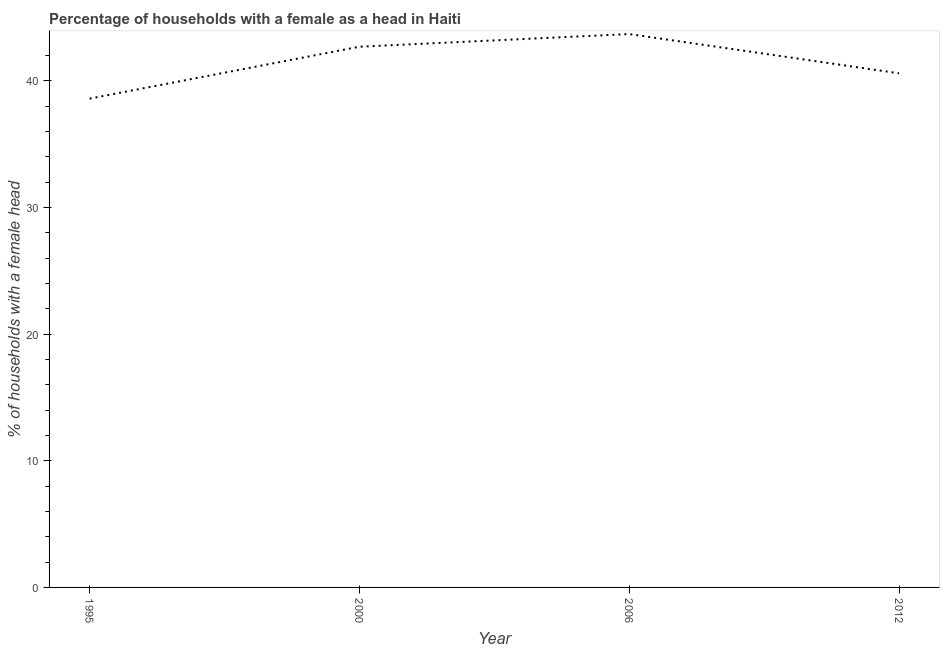What is the number of female supervised households in 2012?
Provide a succinct answer. 40.6. Across all years, what is the maximum number of female supervised households?
Provide a succinct answer. 43.7. Across all years, what is the minimum number of female supervised households?
Provide a succinct answer. 38.6. In which year was the number of female supervised households maximum?
Make the answer very short. 2006. What is the sum of the number of female supervised households?
Your response must be concise. 165.6. What is the difference between the number of female supervised households in 1995 and 2000?
Keep it short and to the point. -4.1. What is the average number of female supervised households per year?
Provide a short and direct response. 41.4. What is the median number of female supervised households?
Your response must be concise. 41.65. What is the ratio of the number of female supervised households in 2006 to that in 2012?
Offer a terse response. 1.08. Is the sum of the number of female supervised households in 1995 and 2006 greater than the maximum number of female supervised households across all years?
Give a very brief answer. Yes. What is the difference between the highest and the lowest number of female supervised households?
Make the answer very short. 5.1. Are the values on the major ticks of Y-axis written in scientific E-notation?
Your response must be concise. No. Does the graph contain any zero values?
Make the answer very short. No. Does the graph contain grids?
Provide a short and direct response. No. What is the title of the graph?
Offer a terse response. Percentage of households with a female as a head in Haiti. What is the label or title of the Y-axis?
Provide a short and direct response. % of households with a female head. What is the % of households with a female head in 1995?
Offer a terse response. 38.6. What is the % of households with a female head in 2000?
Give a very brief answer. 42.7. What is the % of households with a female head of 2006?
Provide a succinct answer. 43.7. What is the % of households with a female head of 2012?
Ensure brevity in your answer.  40.6. What is the difference between the % of households with a female head in 1995 and 2006?
Ensure brevity in your answer.  -5.1. What is the difference between the % of households with a female head in 1995 and 2012?
Ensure brevity in your answer.  -2. What is the difference between the % of households with a female head in 2006 and 2012?
Offer a terse response. 3.1. What is the ratio of the % of households with a female head in 1995 to that in 2000?
Your answer should be compact. 0.9. What is the ratio of the % of households with a female head in 1995 to that in 2006?
Your response must be concise. 0.88. What is the ratio of the % of households with a female head in 1995 to that in 2012?
Provide a succinct answer. 0.95. What is the ratio of the % of households with a female head in 2000 to that in 2006?
Provide a short and direct response. 0.98. What is the ratio of the % of households with a female head in 2000 to that in 2012?
Ensure brevity in your answer.  1.05. What is the ratio of the % of households with a female head in 2006 to that in 2012?
Make the answer very short. 1.08. 